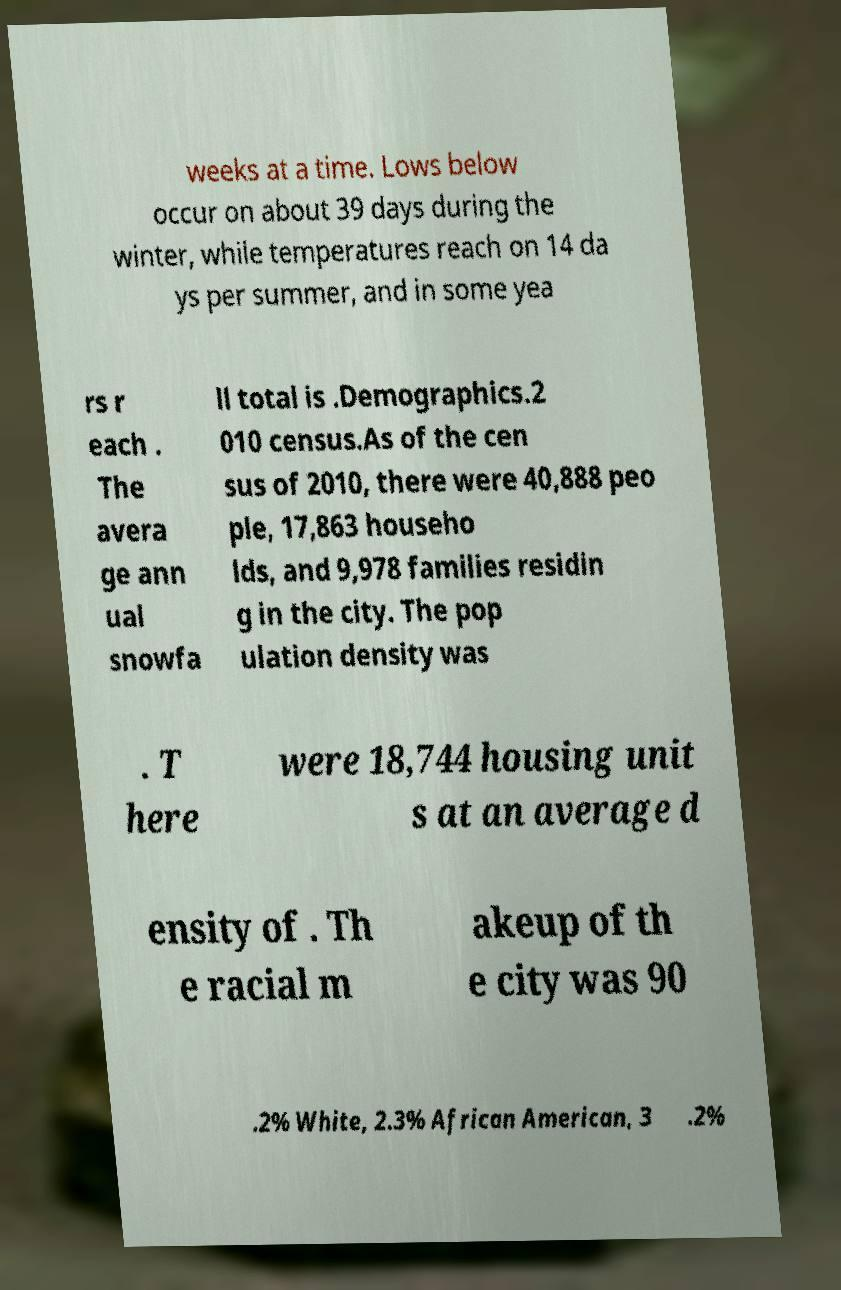I need the written content from this picture converted into text. Can you do that? weeks at a time. Lows below occur on about 39 days during the winter, while temperatures reach on 14 da ys per summer, and in some yea rs r each . The avera ge ann ual snowfa ll total is .Demographics.2 010 census.As of the cen sus of 2010, there were 40,888 peo ple, 17,863 househo lds, and 9,978 families residin g in the city. The pop ulation density was . T here were 18,744 housing unit s at an average d ensity of . Th e racial m akeup of th e city was 90 .2% White, 2.3% African American, 3 .2% 